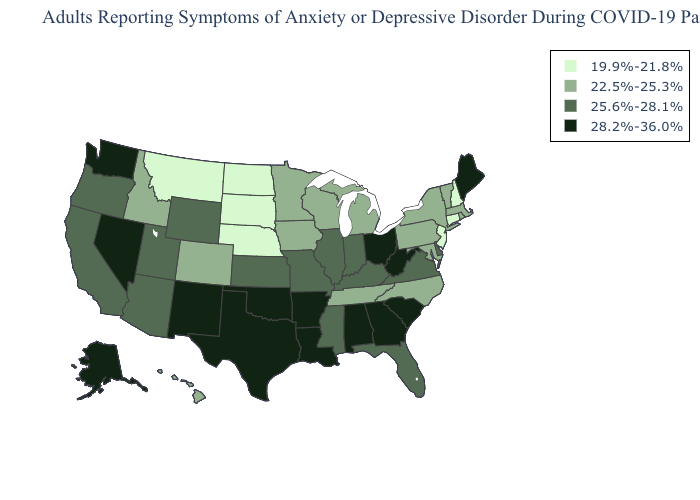What is the value of Nebraska?
Quick response, please. 19.9%-21.8%. Which states have the lowest value in the USA?
Write a very short answer. Connecticut, Montana, Nebraska, New Hampshire, New Jersey, North Dakota, South Dakota. Does Vermont have the highest value in the USA?
Keep it brief. No. What is the highest value in the USA?
Short answer required. 28.2%-36.0%. Does Alaska have the highest value in the West?
Concise answer only. Yes. Name the states that have a value in the range 25.6%-28.1%?
Concise answer only. Arizona, California, Delaware, Florida, Illinois, Indiana, Kansas, Kentucky, Mississippi, Missouri, Oregon, Utah, Virginia, Wyoming. What is the value of Michigan?
Write a very short answer. 22.5%-25.3%. Does Rhode Island have a lower value than Arizona?
Quick response, please. Yes. Does Nevada have a lower value than Tennessee?
Concise answer only. No. Which states have the highest value in the USA?
Concise answer only. Alabama, Alaska, Arkansas, Georgia, Louisiana, Maine, Nevada, New Mexico, Ohio, Oklahoma, South Carolina, Texas, Washington, West Virginia. What is the highest value in states that border Vermont?
Keep it brief. 22.5%-25.3%. What is the lowest value in states that border Louisiana?
Concise answer only. 25.6%-28.1%. Among the states that border Wisconsin , does Iowa have the lowest value?
Be succinct. Yes. Among the states that border Iowa , which have the highest value?
Write a very short answer. Illinois, Missouri. Among the states that border New York , does Pennsylvania have the lowest value?
Concise answer only. No. 